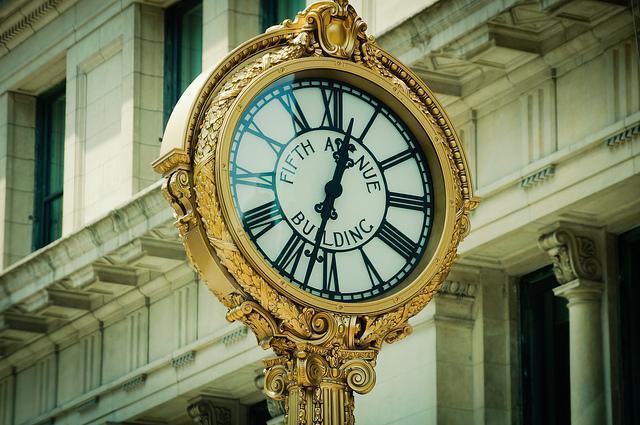How many numbers are on this clock?
Give a very brief answer. 12. How many people are wearing shorts?
Give a very brief answer. 0. 